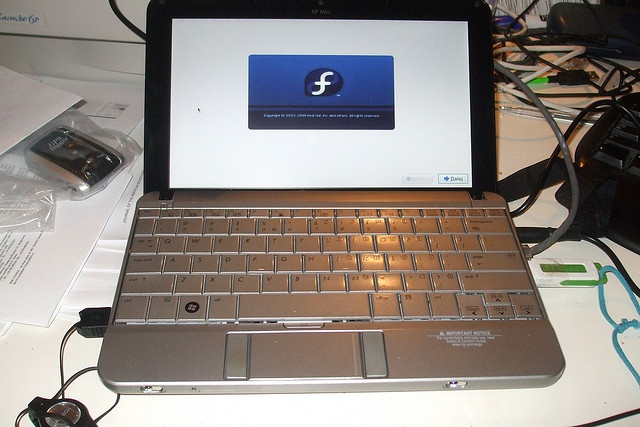Describe the objects in this image and their specific colors. I can see laptop in gray, lightgray, and black tones, keyboard in gray, black, maroon, and darkgray tones, and mouse in gray, black, and darkgray tones in this image. 